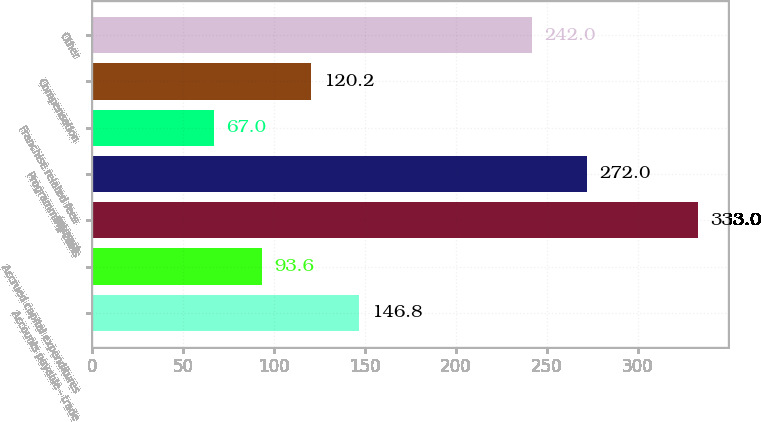<chart> <loc_0><loc_0><loc_500><loc_500><bar_chart><fcel>Accounts payable - trade<fcel>Accrued capital expenditures<fcel>Interest<fcel>Programming costs<fcel>Franchise related fees<fcel>Compensation<fcel>Other<nl><fcel>146.8<fcel>93.6<fcel>333<fcel>272<fcel>67<fcel>120.2<fcel>242<nl></chart> 